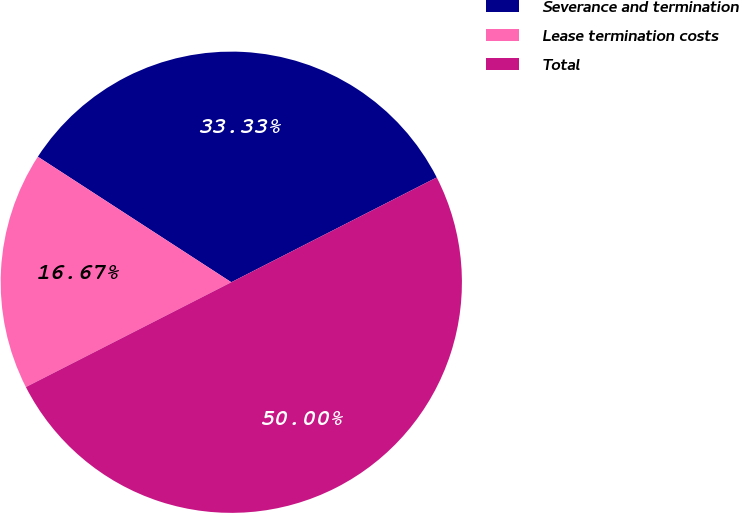Convert chart to OTSL. <chart><loc_0><loc_0><loc_500><loc_500><pie_chart><fcel>Severance and termination<fcel>Lease termination costs<fcel>Total<nl><fcel>33.33%<fcel>16.67%<fcel>50.0%<nl></chart> 